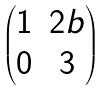Convert formula to latex. <formula><loc_0><loc_0><loc_500><loc_500>\begin{pmatrix} 1 & 2 b \\ 0 & 3 \end{pmatrix}</formula> 